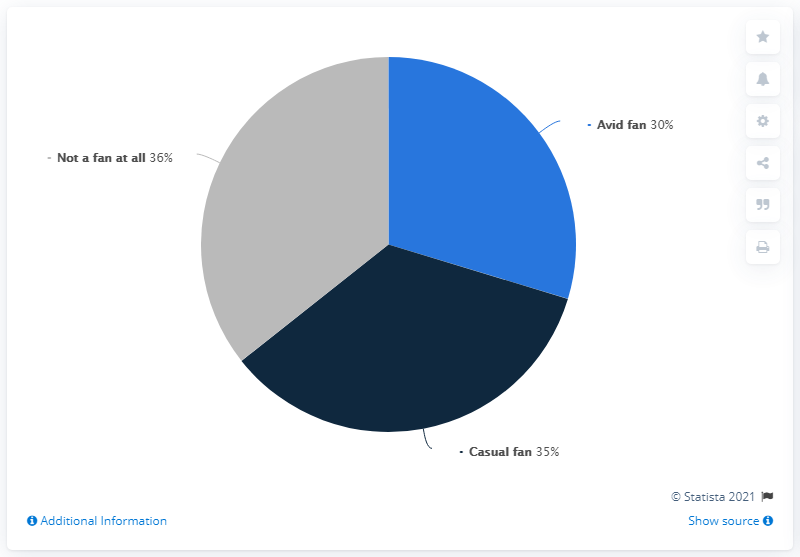What is interest of avid fan? Based on the pie chart in the image, the interest of an avid fan would be quite high, as it shows that 30% of the respondents identify as avid fans, which suggests a strong engagement and dedication to their interest or fandom. 